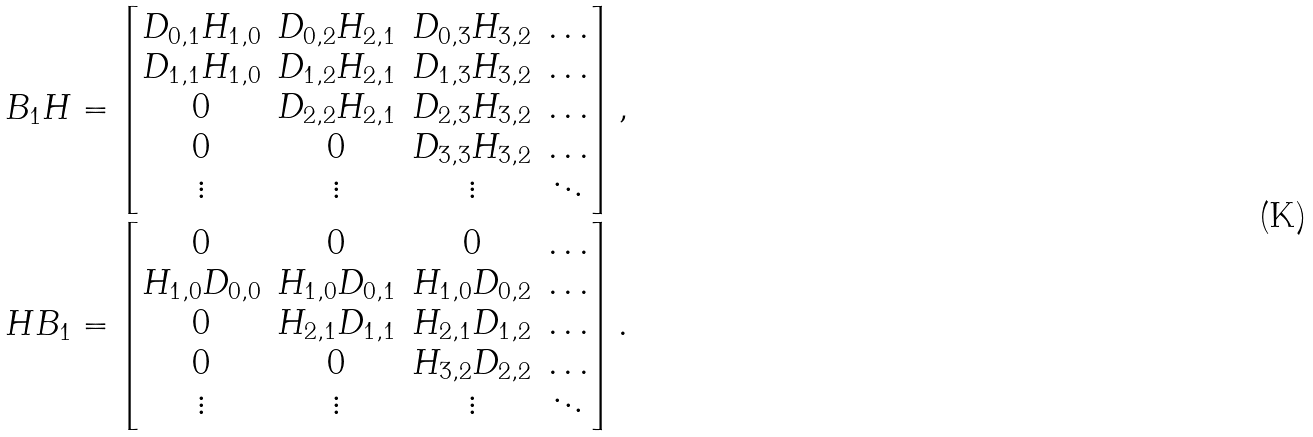Convert formula to latex. <formula><loc_0><loc_0><loc_500><loc_500>B _ { 1 } H = \begin{bmatrix} D _ { 0 , 1 } H _ { 1 , 0 } & D _ { 0 , 2 } H _ { 2 , 1 } & D _ { 0 , 3 } H _ { 3 , 2 } & \dots \\ D _ { 1 , 1 } H _ { 1 , 0 } & D _ { 1 , 2 } H _ { 2 , 1 } & D _ { 1 , 3 } H _ { 3 , 2 } & \dots \\ 0 & D _ { 2 , 2 } H _ { 2 , 1 } & D _ { 2 , 3 } H _ { 3 , 2 } & \dots \\ 0 & 0 & D _ { 3 , 3 } H _ { 3 , 2 } & \dots \\ \vdots & \vdots & \vdots & \ddots \end{bmatrix} , \\ H B _ { 1 } = \begin{bmatrix} 0 & 0 & 0 & \dots \\ H _ { 1 , 0 } D _ { 0 , 0 } & H _ { 1 , 0 } D _ { 0 , 1 } & H _ { 1 , 0 } D _ { 0 , 2 } & \dots \\ 0 & H _ { 2 , 1 } D _ { 1 , 1 } & H _ { 2 , 1 } D _ { 1 , 2 } & \dots \\ 0 & 0 & H _ { 3 , 2 } D _ { 2 , 2 } & \dots \\ \vdots & \vdots & \vdots & \ddots \end{bmatrix} .</formula> 